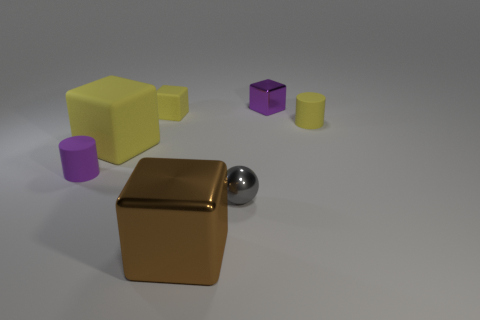Are there fewer metal things than big green things?
Your answer should be compact. No. There is a big brown shiny thing; does it have the same shape as the small shiny thing that is in front of the tiny yellow rubber block?
Offer a very short reply. No. Does the yellow object on the right side of the purple metallic block have the same size as the gray object?
Provide a succinct answer. Yes. What is the shape of the purple rubber thing that is the same size as the purple block?
Provide a short and direct response. Cylinder. Is the shape of the purple matte object the same as the brown metal object?
Your answer should be compact. No. What number of other brown things have the same shape as the big brown object?
Your answer should be very brief. 0. How many metal objects are on the left side of the tiny metallic block?
Your answer should be compact. 2. Is the color of the cylinder that is to the right of the gray shiny thing the same as the tiny metallic block?
Give a very brief answer. No. What number of yellow matte cubes have the same size as the brown metal object?
Your response must be concise. 1. What shape is the tiny purple thing that is the same material as the brown block?
Your response must be concise. Cube. 